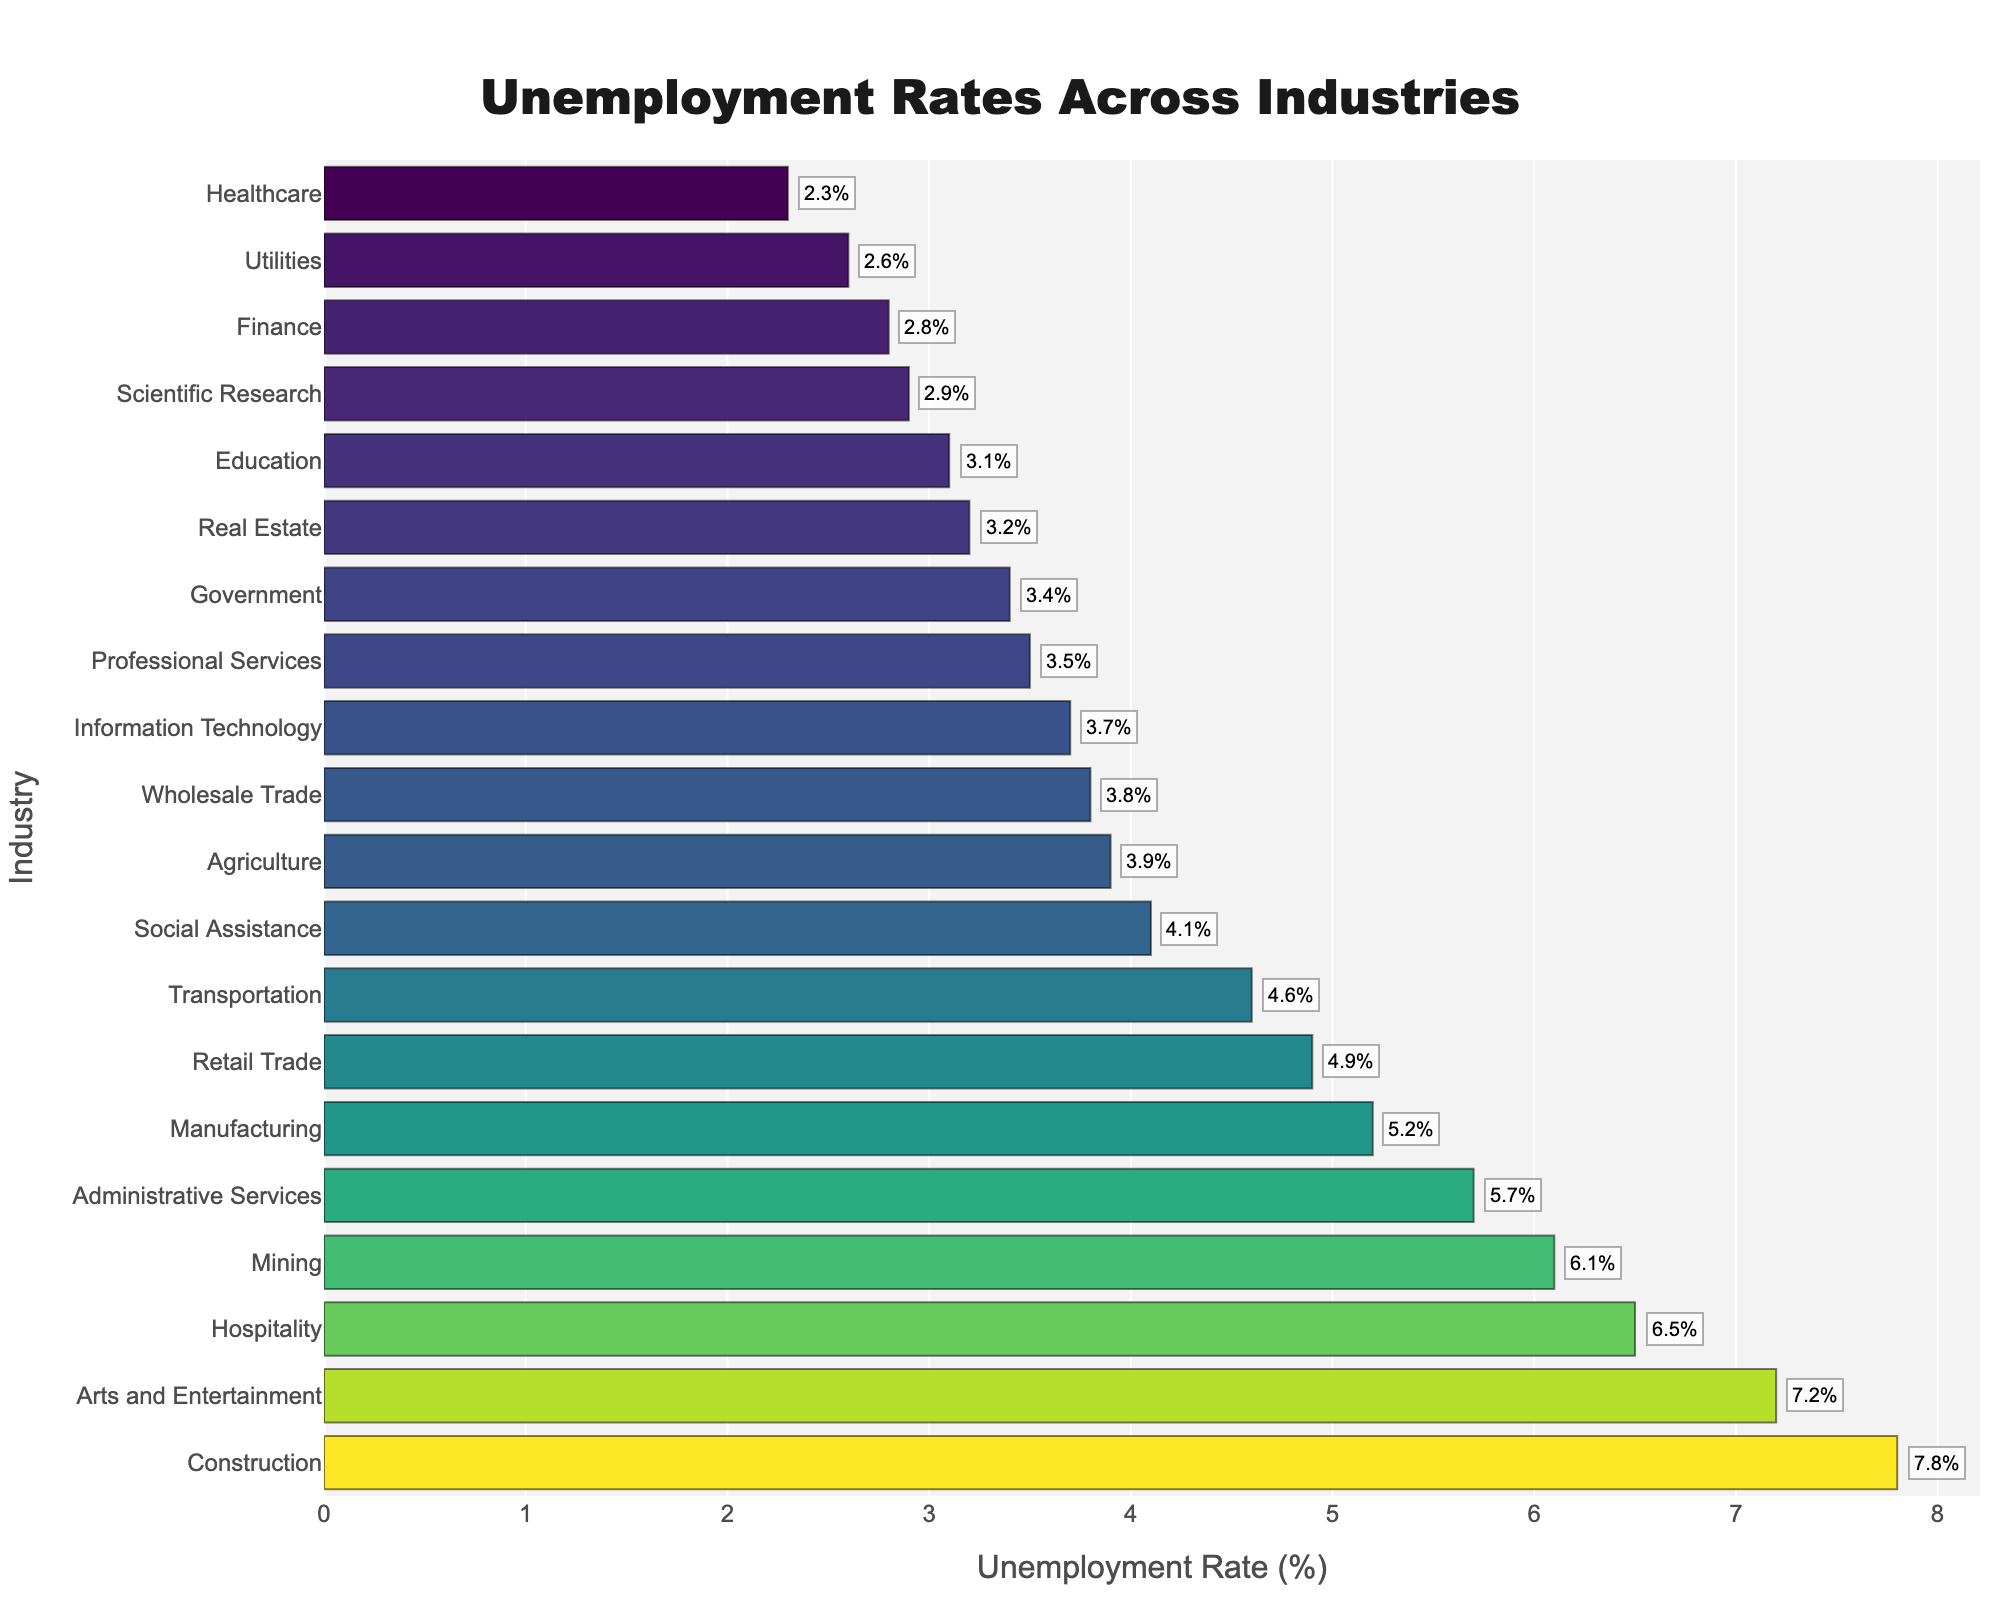What is the industry with the highest unemployment rate? By looking at the bar chart, the industry on the top with the longest bar represents the highest unemployment rate.
Answer: Construction What is the industry with the lowest unemployment rate? By looking at the bar chart, the industry on the bottom with the shortest bar represents the lowest unemployment rate.
Answer: Healthcare How much higher is the unemployment rate in Construction compared to Information Technology? First, note the unemployment rate for Construction (7.8%) and Information Technology (3.7%). Compute the difference: 7.8% - 3.7% = 4.1%.
Answer: 4.1% What is the median unemployment rate across all industries shown? The median value is the middle value when the unemployment rates are ordered from lowest to highest. The median can be visually estimated or calculated using the sorted data. In this case, there are 20 industries, so the median is the average of the 10th and 11th values in the sorted list. The 10th and 11th values in the sorted list are both 3.9%. So the median is (3.9% + 3.9%) / 2 = 3.5%.
Answer: 3.5% Among Real Estate, Education, and Information Technology, which industry has the highest unemployment rate? Compare the bar lengths for Real Estate (3.2%), Education (3.1%), and Information Technology (3.7%).
Answer: Information Technology Is the unemployment rate in Wholesale Trade higher or lower than in Social Assistance? By comparing bar lengths or percentages on the chart, Wholesale Trade (3.8%) is lower than Social Assistance (4.1%).
Answer: Lower What is the average unemployment rate for the industries listed? Sum all unemployment rates and divide by the number of industries. Sum = 5.2 + 7.8 + 4.9 + 2.3 + 3.1 + 3.7 + 2.8 + 6.5 + 4.6 + 3.4 + 3.9 + 6.1 + 3.2 + 3.5 + 2.6 + 7.2 + 3.8 + 2.9 + 5.7 + 4.1 = 84.6. Number of industries = 20. Average = 84.6 / 20 = 4.23%.
Answer: 4.23% What is the difference in unemployment rates between the highest and lowest industries? Calculate the difference: highest (Construction, 7.8%) - lowest (Healthcare, 2.3%). Difference = 7.8% - 2.3% = 5.5%.
Answer: 5.5% Which industries have unemployment rates above 6%? Based on the chart, identify all industries with bars extending beyond 6%. These are Construction (7.8%), Hospitality (6.5%), Mining (6.1%), and Arts and Entertainment (7.2%).
Answer: Construction, Hospitality, Mining, Arts and Entertainment 